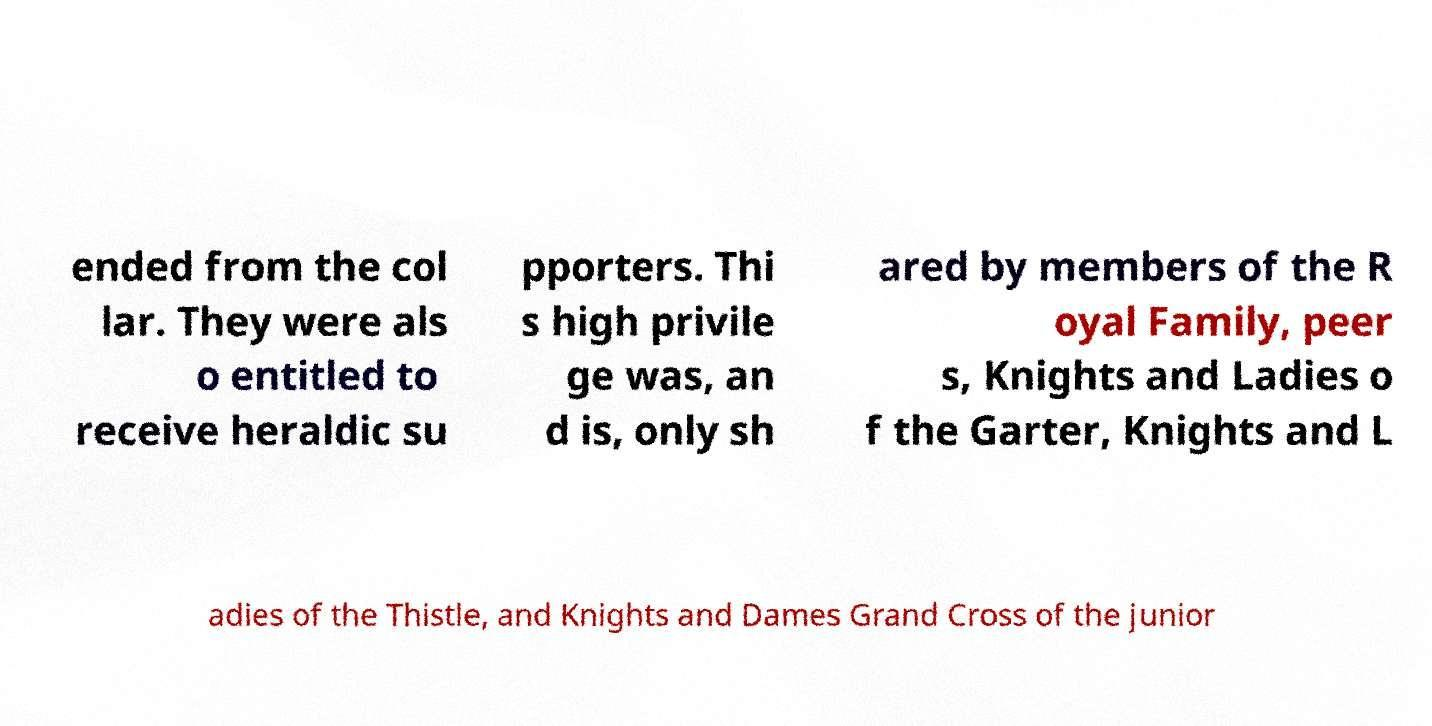Can you accurately transcribe the text from the provided image for me? ended from the col lar. They were als o entitled to receive heraldic su pporters. Thi s high privile ge was, an d is, only sh ared by members of the R oyal Family, peer s, Knights and Ladies o f the Garter, Knights and L adies of the Thistle, and Knights and Dames Grand Cross of the junior 